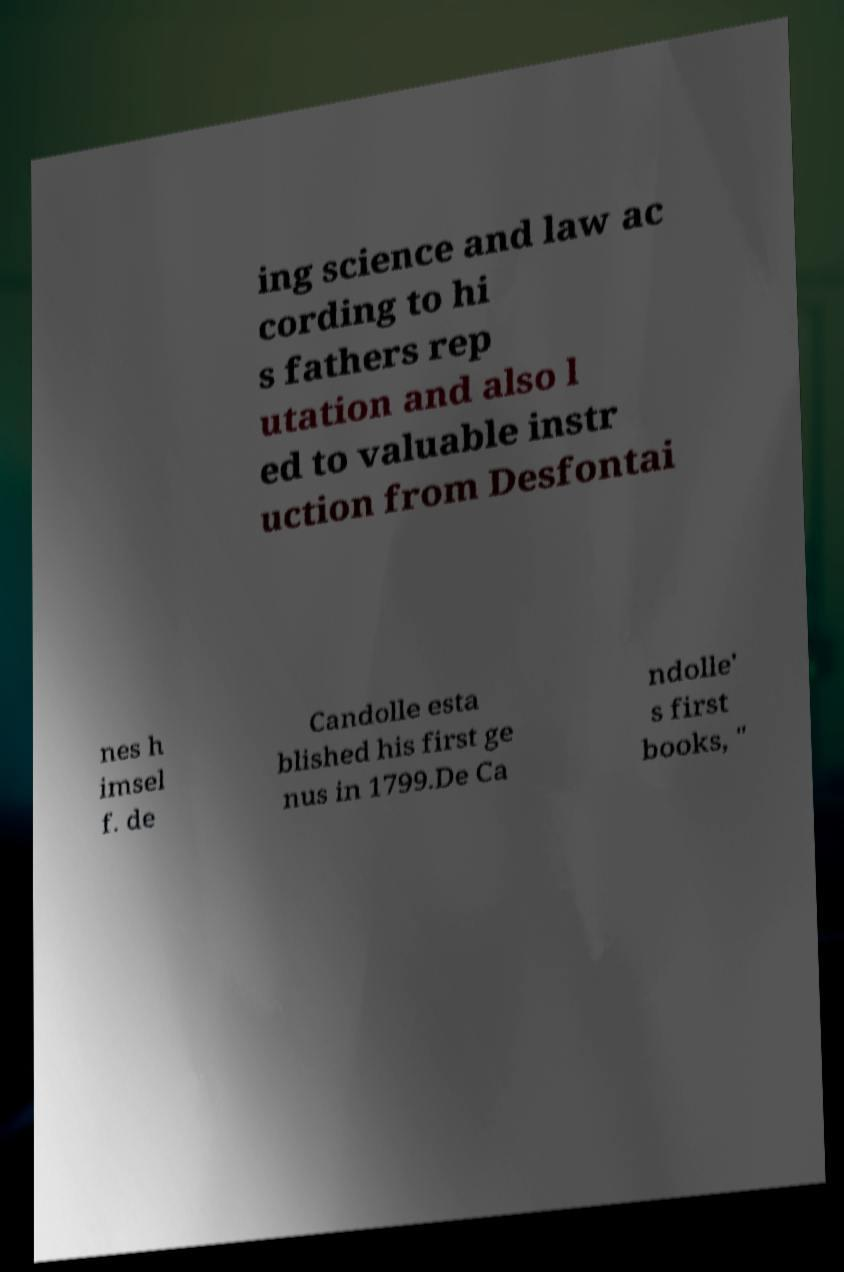Could you extract and type out the text from this image? ing science and law ac cording to hi s fathers rep utation and also l ed to valuable instr uction from Desfontai nes h imsel f. de Candolle esta blished his first ge nus in 1799.De Ca ndolle' s first books, " 